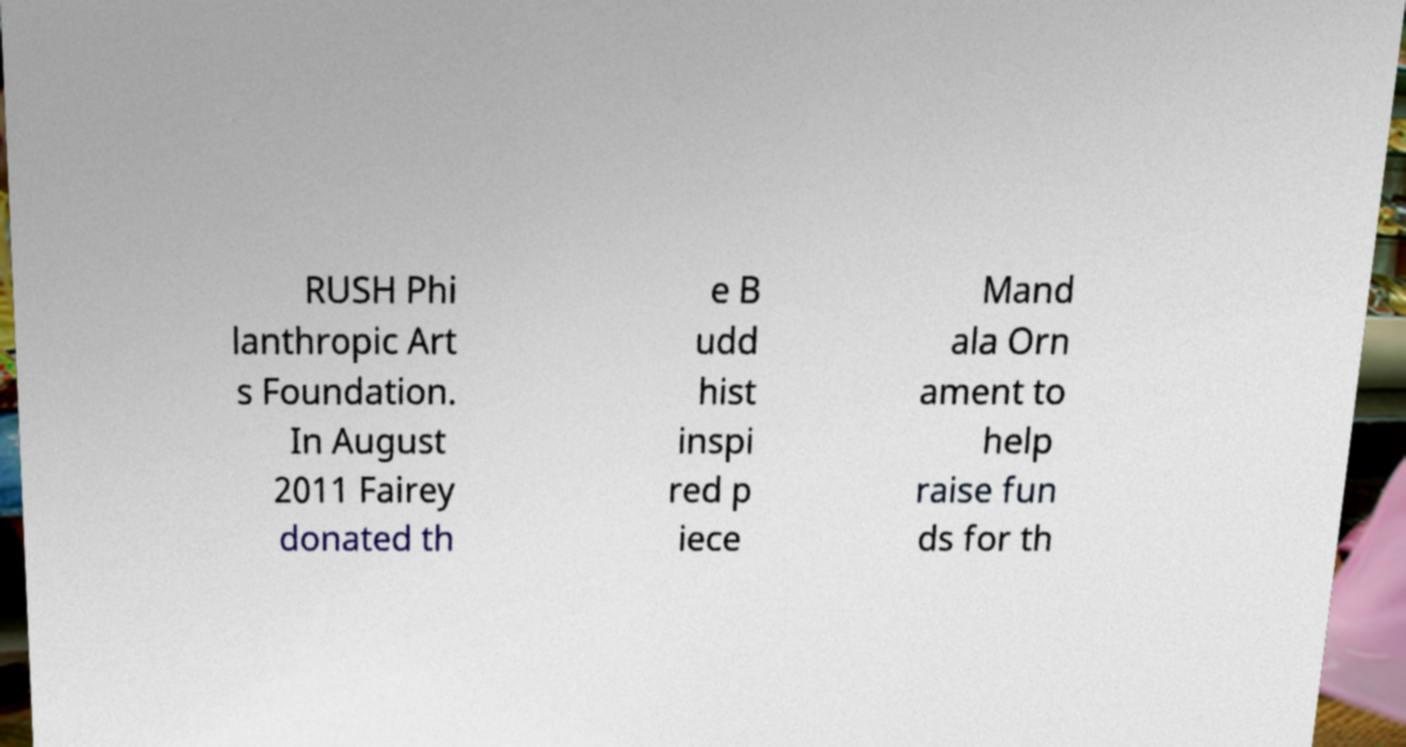Please read and relay the text visible in this image. What does it say? RUSH Phi lanthropic Art s Foundation. In August 2011 Fairey donated th e B udd hist inspi red p iece Mand ala Orn ament to help raise fun ds for th 